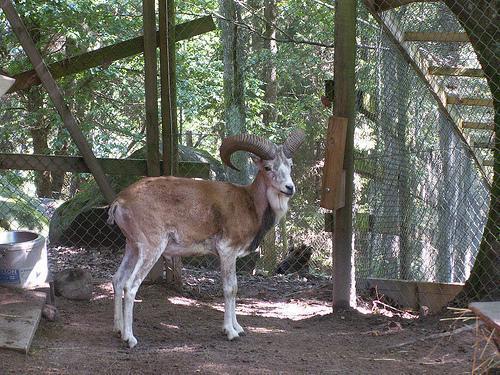How many goats are there?
Give a very brief answer. 1. How many horns are there?
Give a very brief answer. 2. 